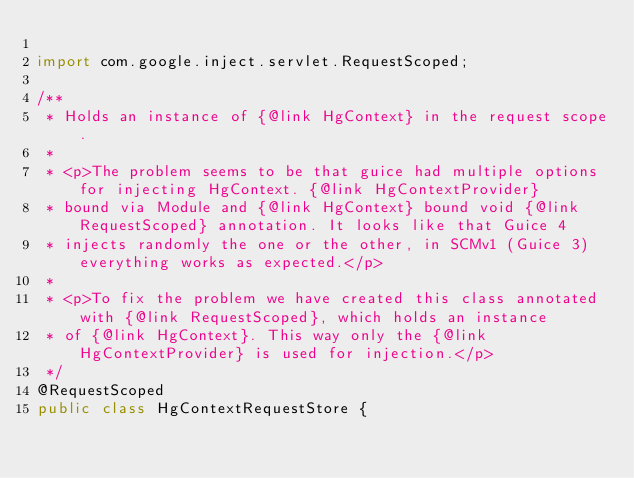<code> <loc_0><loc_0><loc_500><loc_500><_Java_>
import com.google.inject.servlet.RequestScoped;

/**
 * Holds an instance of {@link HgContext} in the request scope.
 *
 * <p>The problem seems to be that guice had multiple options for injecting HgContext. {@link HgContextProvider}
 * bound via Module and {@link HgContext} bound void {@link RequestScoped} annotation. It looks like that Guice 4
 * injects randomly the one or the other, in SCMv1 (Guice 3) everything works as expected.</p>
 *
 * <p>To fix the problem we have created this class annotated with {@link RequestScoped}, which holds an instance
 * of {@link HgContext}. This way only the {@link HgContextProvider} is used for injection.</p>
 */
@RequestScoped
public class HgContextRequestStore {
</code> 